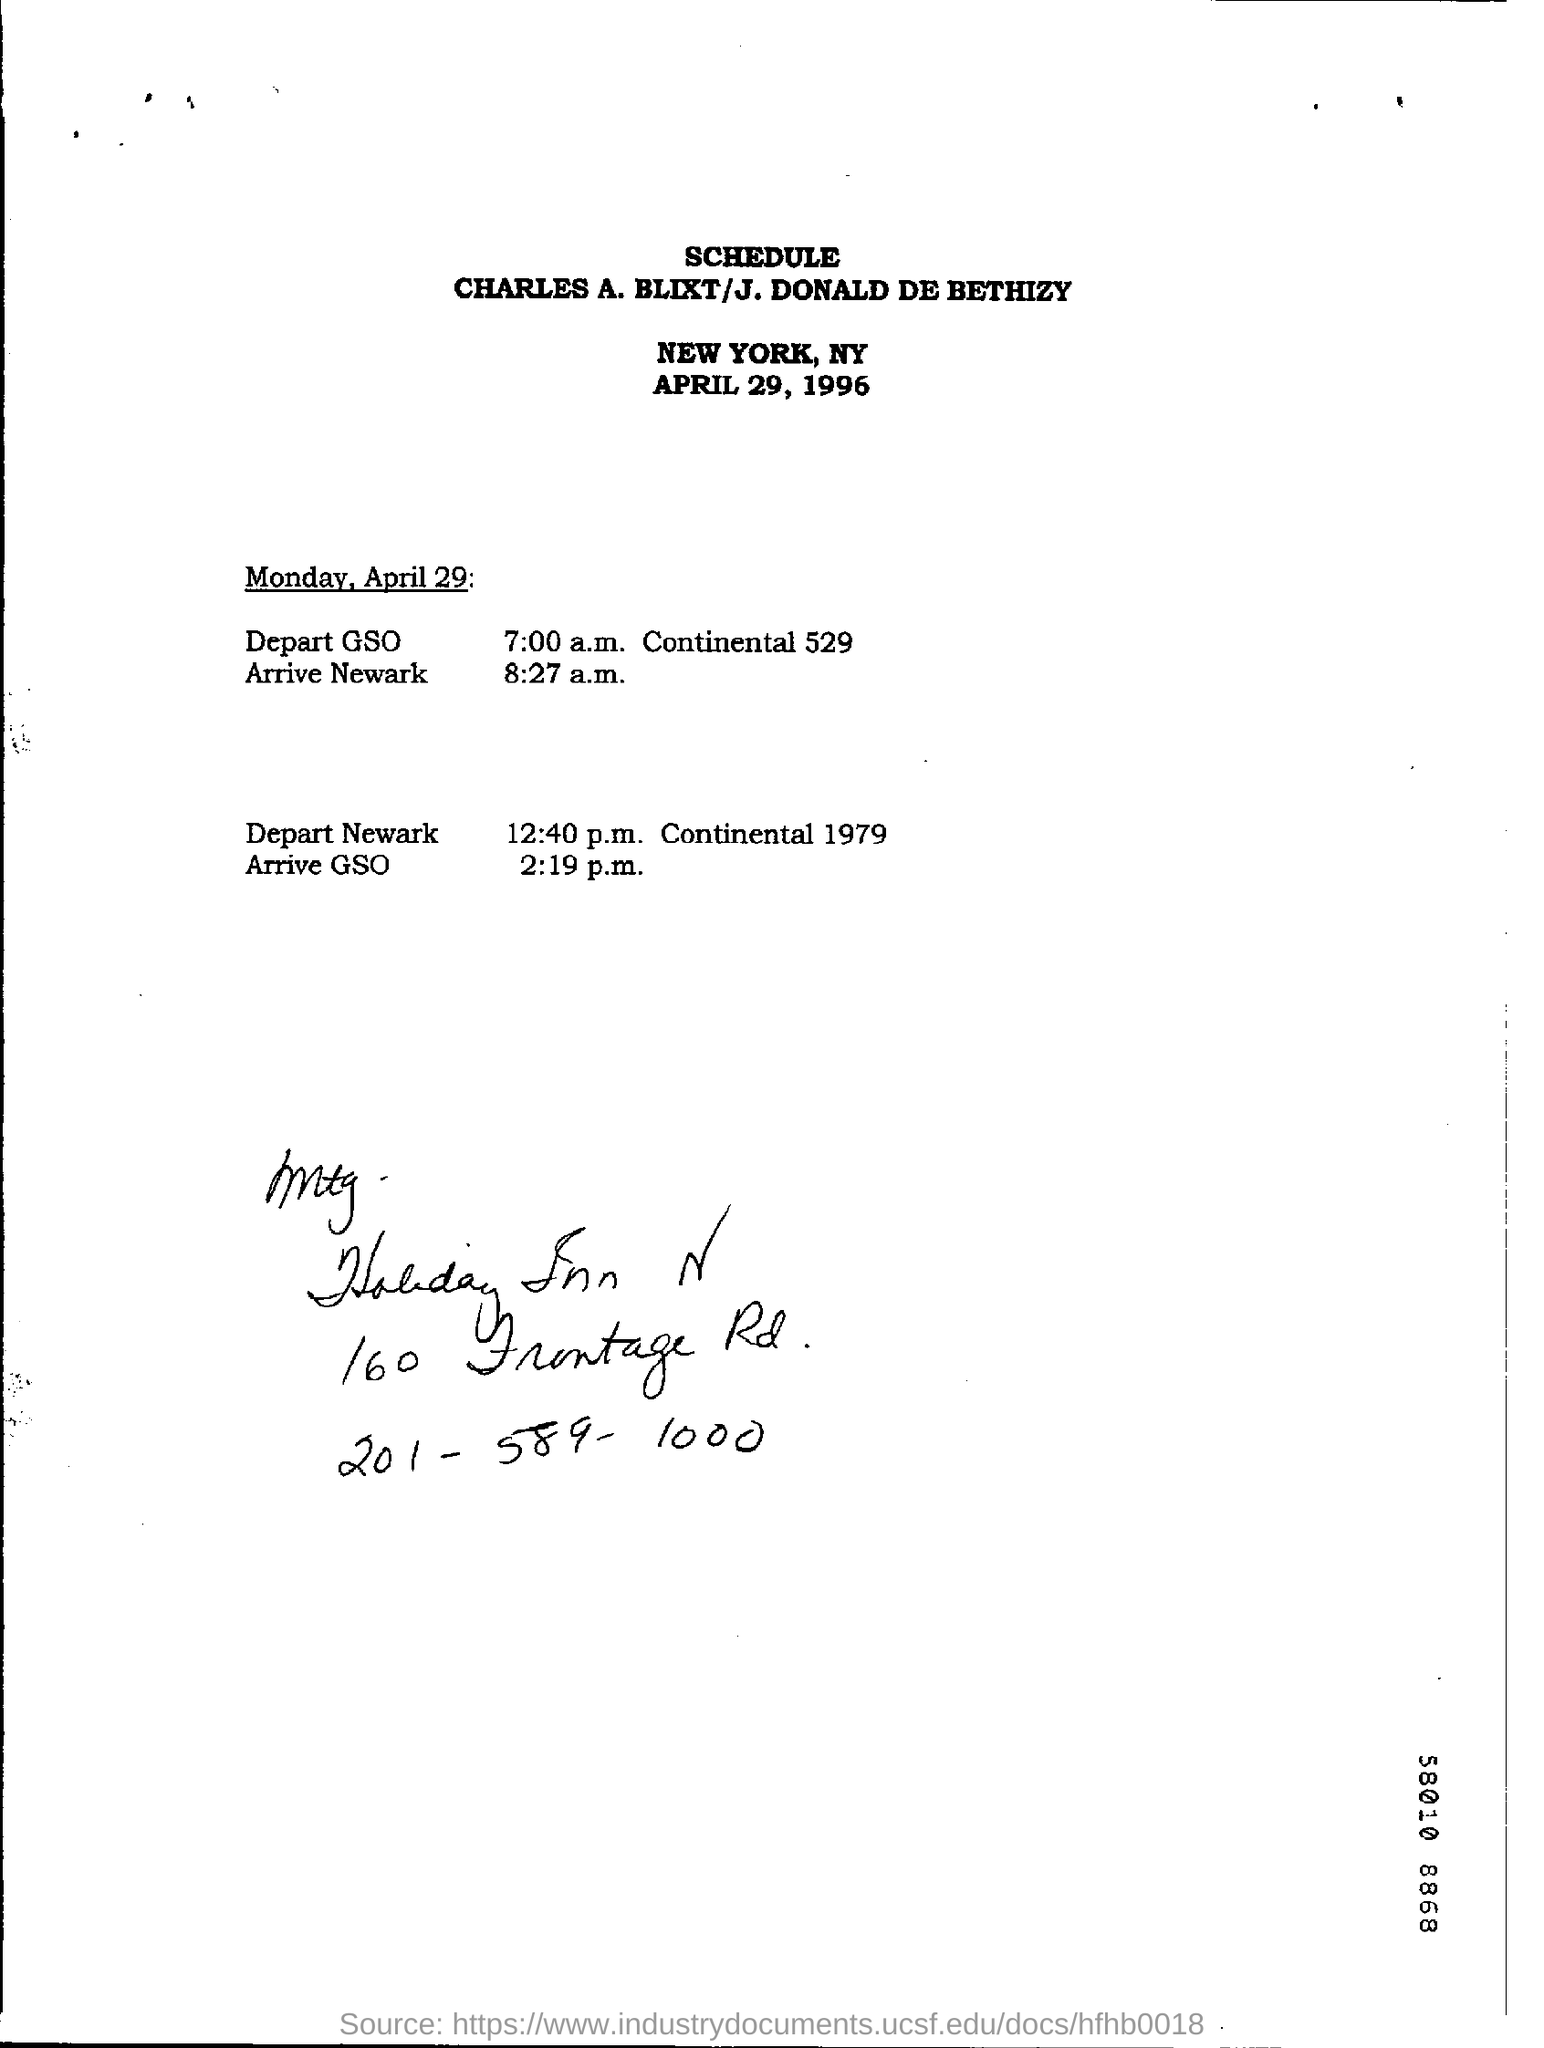What is the date on the document?
Keep it short and to the point. April 29 , 1996. When is the Arrival at Newark?
Provide a short and direct response. 8:27 a.m. When is the Arrival at GSO?
Your answer should be compact. 2:19 p.m. When is the Departure from Newark?
Your response must be concise. 12:40 p.m. 